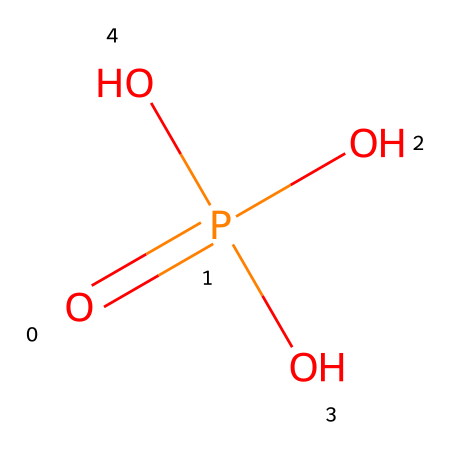What is the molecular formula for this compound? To determine the molecular formula, count the number of each type of atom in the chemical structure represented by the SMILES. Here, there is one phosphorus atom (P) and four oxygen atoms (O), giving us the formula H₃PO₄.
Answer: H₃PO₄ How many oxygen atoms are present in the structure? The SMILES representation shows 'O' four times, indicating there are four oxygen atoms present in the chemical structure.
Answer: 4 What is the common name of this compound? Phosphoric acid is a well-known name for H₃PO₄, which is recognizable due to its frequent use in food and beverages, such as cola drinks.
Answer: phosphoric acid Is this compound an acid or a base? Phosphoric acid is classified as an acid because it has a pH less than 7 in aqueous solutions and can donate protons (H⁺) in reactions.
Answer: acid What role does phosphoric acid play in cola drinks? Phosphoric acid is used as a flavoring agent to provide acidity and enhance the overall taste profile of cola drinks.
Answer: flavoring agent How many hydrogens are in this compound? The structure indicates there are three hydrogen atoms bonded to the oxygen atoms in the phosphoric acid molecule, as suggested by 'H₃' in its molecular formula.
Answer: 3 What type of chemical is represented by this SMILES notation? The SMILES notation indicates this compound is an organophosphoric compound due to the presence of phosphorus and oxygen, which is typical for phosphoric acids.
Answer: organophosphoric compound 